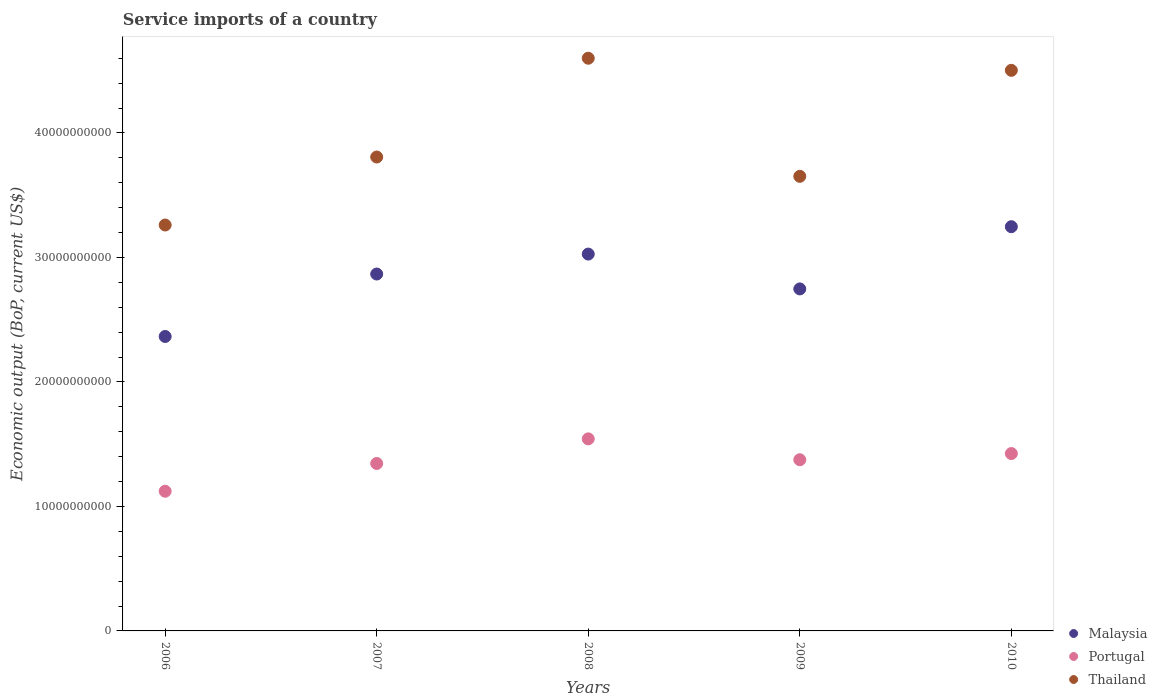How many different coloured dotlines are there?
Make the answer very short. 3. What is the service imports in Portugal in 2009?
Make the answer very short. 1.38e+1. Across all years, what is the maximum service imports in Thailand?
Ensure brevity in your answer.  4.60e+1. Across all years, what is the minimum service imports in Portugal?
Your answer should be very brief. 1.12e+1. What is the total service imports in Portugal in the graph?
Give a very brief answer. 6.81e+1. What is the difference between the service imports in Malaysia in 2008 and that in 2009?
Your answer should be very brief. 2.80e+09. What is the difference between the service imports in Portugal in 2006 and the service imports in Thailand in 2008?
Your response must be concise. -3.48e+1. What is the average service imports in Malaysia per year?
Offer a very short reply. 2.85e+1. In the year 2007, what is the difference between the service imports in Thailand and service imports in Malaysia?
Your response must be concise. 9.40e+09. What is the ratio of the service imports in Thailand in 2006 to that in 2007?
Make the answer very short. 0.86. Is the service imports in Malaysia in 2006 less than that in 2009?
Provide a short and direct response. Yes. What is the difference between the highest and the second highest service imports in Portugal?
Keep it short and to the point. 1.18e+09. What is the difference between the highest and the lowest service imports in Portugal?
Provide a succinct answer. 4.21e+09. Is the sum of the service imports in Thailand in 2007 and 2008 greater than the maximum service imports in Portugal across all years?
Your answer should be compact. Yes. Is it the case that in every year, the sum of the service imports in Portugal and service imports in Thailand  is greater than the service imports in Malaysia?
Offer a terse response. Yes. Does the service imports in Thailand monotonically increase over the years?
Make the answer very short. No. Is the service imports in Malaysia strictly less than the service imports in Thailand over the years?
Make the answer very short. Yes. How many dotlines are there?
Your response must be concise. 3. How many years are there in the graph?
Your answer should be very brief. 5. What is the difference between two consecutive major ticks on the Y-axis?
Give a very brief answer. 1.00e+1. Does the graph contain any zero values?
Keep it short and to the point. No. Does the graph contain grids?
Ensure brevity in your answer.  No. How are the legend labels stacked?
Your answer should be very brief. Vertical. What is the title of the graph?
Give a very brief answer. Service imports of a country. What is the label or title of the X-axis?
Ensure brevity in your answer.  Years. What is the label or title of the Y-axis?
Offer a very short reply. Economic output (BoP, current US$). What is the Economic output (BoP, current US$) in Malaysia in 2006?
Keep it short and to the point. 2.37e+1. What is the Economic output (BoP, current US$) of Portugal in 2006?
Keep it short and to the point. 1.12e+1. What is the Economic output (BoP, current US$) in Thailand in 2006?
Make the answer very short. 3.26e+1. What is the Economic output (BoP, current US$) of Malaysia in 2007?
Ensure brevity in your answer.  2.87e+1. What is the Economic output (BoP, current US$) of Portugal in 2007?
Keep it short and to the point. 1.34e+1. What is the Economic output (BoP, current US$) in Thailand in 2007?
Offer a terse response. 3.81e+1. What is the Economic output (BoP, current US$) in Malaysia in 2008?
Make the answer very short. 3.03e+1. What is the Economic output (BoP, current US$) of Portugal in 2008?
Offer a terse response. 1.54e+1. What is the Economic output (BoP, current US$) in Thailand in 2008?
Provide a succinct answer. 4.60e+1. What is the Economic output (BoP, current US$) of Malaysia in 2009?
Ensure brevity in your answer.  2.75e+1. What is the Economic output (BoP, current US$) of Portugal in 2009?
Provide a succinct answer. 1.38e+1. What is the Economic output (BoP, current US$) in Thailand in 2009?
Ensure brevity in your answer.  3.65e+1. What is the Economic output (BoP, current US$) of Malaysia in 2010?
Your response must be concise. 3.25e+1. What is the Economic output (BoP, current US$) in Portugal in 2010?
Provide a short and direct response. 1.42e+1. What is the Economic output (BoP, current US$) of Thailand in 2010?
Offer a terse response. 4.50e+1. Across all years, what is the maximum Economic output (BoP, current US$) of Malaysia?
Provide a short and direct response. 3.25e+1. Across all years, what is the maximum Economic output (BoP, current US$) of Portugal?
Offer a very short reply. 1.54e+1. Across all years, what is the maximum Economic output (BoP, current US$) in Thailand?
Offer a terse response. 4.60e+1. Across all years, what is the minimum Economic output (BoP, current US$) of Malaysia?
Your answer should be compact. 2.37e+1. Across all years, what is the minimum Economic output (BoP, current US$) in Portugal?
Your response must be concise. 1.12e+1. Across all years, what is the minimum Economic output (BoP, current US$) in Thailand?
Give a very brief answer. 3.26e+1. What is the total Economic output (BoP, current US$) in Malaysia in the graph?
Your response must be concise. 1.43e+11. What is the total Economic output (BoP, current US$) of Portugal in the graph?
Provide a short and direct response. 6.81e+1. What is the total Economic output (BoP, current US$) in Thailand in the graph?
Provide a short and direct response. 1.98e+11. What is the difference between the Economic output (BoP, current US$) of Malaysia in 2006 and that in 2007?
Offer a terse response. -5.02e+09. What is the difference between the Economic output (BoP, current US$) in Portugal in 2006 and that in 2007?
Give a very brief answer. -2.23e+09. What is the difference between the Economic output (BoP, current US$) in Thailand in 2006 and that in 2007?
Offer a very short reply. -5.46e+09. What is the difference between the Economic output (BoP, current US$) of Malaysia in 2006 and that in 2008?
Your response must be concise. -6.62e+09. What is the difference between the Economic output (BoP, current US$) in Portugal in 2006 and that in 2008?
Provide a short and direct response. -4.21e+09. What is the difference between the Economic output (BoP, current US$) of Thailand in 2006 and that in 2008?
Provide a succinct answer. -1.34e+1. What is the difference between the Economic output (BoP, current US$) of Malaysia in 2006 and that in 2009?
Provide a short and direct response. -3.82e+09. What is the difference between the Economic output (BoP, current US$) of Portugal in 2006 and that in 2009?
Your answer should be very brief. -2.53e+09. What is the difference between the Economic output (BoP, current US$) in Thailand in 2006 and that in 2009?
Provide a short and direct response. -3.91e+09. What is the difference between the Economic output (BoP, current US$) in Malaysia in 2006 and that in 2010?
Ensure brevity in your answer.  -8.82e+09. What is the difference between the Economic output (BoP, current US$) of Portugal in 2006 and that in 2010?
Offer a terse response. -3.03e+09. What is the difference between the Economic output (BoP, current US$) in Thailand in 2006 and that in 2010?
Provide a succinct answer. -1.24e+1. What is the difference between the Economic output (BoP, current US$) of Malaysia in 2007 and that in 2008?
Your answer should be very brief. -1.60e+09. What is the difference between the Economic output (BoP, current US$) of Portugal in 2007 and that in 2008?
Offer a very short reply. -1.98e+09. What is the difference between the Economic output (BoP, current US$) of Thailand in 2007 and that in 2008?
Offer a very short reply. -7.94e+09. What is the difference between the Economic output (BoP, current US$) of Malaysia in 2007 and that in 2009?
Offer a very short reply. 1.20e+09. What is the difference between the Economic output (BoP, current US$) of Portugal in 2007 and that in 2009?
Your response must be concise. -3.01e+08. What is the difference between the Economic output (BoP, current US$) in Thailand in 2007 and that in 2009?
Your answer should be compact. 1.55e+09. What is the difference between the Economic output (BoP, current US$) of Malaysia in 2007 and that in 2010?
Ensure brevity in your answer.  -3.80e+09. What is the difference between the Economic output (BoP, current US$) in Portugal in 2007 and that in 2010?
Make the answer very short. -7.98e+08. What is the difference between the Economic output (BoP, current US$) of Thailand in 2007 and that in 2010?
Give a very brief answer. -6.96e+09. What is the difference between the Economic output (BoP, current US$) in Malaysia in 2008 and that in 2009?
Keep it short and to the point. 2.80e+09. What is the difference between the Economic output (BoP, current US$) of Portugal in 2008 and that in 2009?
Your response must be concise. 1.68e+09. What is the difference between the Economic output (BoP, current US$) of Thailand in 2008 and that in 2009?
Ensure brevity in your answer.  9.49e+09. What is the difference between the Economic output (BoP, current US$) in Malaysia in 2008 and that in 2010?
Offer a very short reply. -2.20e+09. What is the difference between the Economic output (BoP, current US$) in Portugal in 2008 and that in 2010?
Your response must be concise. 1.18e+09. What is the difference between the Economic output (BoP, current US$) in Thailand in 2008 and that in 2010?
Give a very brief answer. 9.72e+08. What is the difference between the Economic output (BoP, current US$) in Malaysia in 2009 and that in 2010?
Ensure brevity in your answer.  -5.00e+09. What is the difference between the Economic output (BoP, current US$) of Portugal in 2009 and that in 2010?
Offer a very short reply. -4.96e+08. What is the difference between the Economic output (BoP, current US$) of Thailand in 2009 and that in 2010?
Give a very brief answer. -8.51e+09. What is the difference between the Economic output (BoP, current US$) of Malaysia in 2006 and the Economic output (BoP, current US$) of Portugal in 2007?
Your response must be concise. 1.02e+1. What is the difference between the Economic output (BoP, current US$) in Malaysia in 2006 and the Economic output (BoP, current US$) in Thailand in 2007?
Your response must be concise. -1.44e+1. What is the difference between the Economic output (BoP, current US$) in Portugal in 2006 and the Economic output (BoP, current US$) in Thailand in 2007?
Provide a short and direct response. -2.68e+1. What is the difference between the Economic output (BoP, current US$) in Malaysia in 2006 and the Economic output (BoP, current US$) in Portugal in 2008?
Make the answer very short. 8.22e+09. What is the difference between the Economic output (BoP, current US$) in Malaysia in 2006 and the Economic output (BoP, current US$) in Thailand in 2008?
Give a very brief answer. -2.24e+1. What is the difference between the Economic output (BoP, current US$) in Portugal in 2006 and the Economic output (BoP, current US$) in Thailand in 2008?
Offer a very short reply. -3.48e+1. What is the difference between the Economic output (BoP, current US$) in Malaysia in 2006 and the Economic output (BoP, current US$) in Portugal in 2009?
Your answer should be very brief. 9.90e+09. What is the difference between the Economic output (BoP, current US$) of Malaysia in 2006 and the Economic output (BoP, current US$) of Thailand in 2009?
Offer a very short reply. -1.29e+1. What is the difference between the Economic output (BoP, current US$) of Portugal in 2006 and the Economic output (BoP, current US$) of Thailand in 2009?
Give a very brief answer. -2.53e+1. What is the difference between the Economic output (BoP, current US$) in Malaysia in 2006 and the Economic output (BoP, current US$) in Portugal in 2010?
Provide a short and direct response. 9.40e+09. What is the difference between the Economic output (BoP, current US$) in Malaysia in 2006 and the Economic output (BoP, current US$) in Thailand in 2010?
Ensure brevity in your answer.  -2.14e+1. What is the difference between the Economic output (BoP, current US$) of Portugal in 2006 and the Economic output (BoP, current US$) of Thailand in 2010?
Provide a short and direct response. -3.38e+1. What is the difference between the Economic output (BoP, current US$) of Malaysia in 2007 and the Economic output (BoP, current US$) of Portugal in 2008?
Offer a very short reply. 1.32e+1. What is the difference between the Economic output (BoP, current US$) in Malaysia in 2007 and the Economic output (BoP, current US$) in Thailand in 2008?
Provide a short and direct response. -1.73e+1. What is the difference between the Economic output (BoP, current US$) of Portugal in 2007 and the Economic output (BoP, current US$) of Thailand in 2008?
Provide a short and direct response. -3.26e+1. What is the difference between the Economic output (BoP, current US$) of Malaysia in 2007 and the Economic output (BoP, current US$) of Portugal in 2009?
Keep it short and to the point. 1.49e+1. What is the difference between the Economic output (BoP, current US$) of Malaysia in 2007 and the Economic output (BoP, current US$) of Thailand in 2009?
Offer a very short reply. -7.85e+09. What is the difference between the Economic output (BoP, current US$) of Portugal in 2007 and the Economic output (BoP, current US$) of Thailand in 2009?
Give a very brief answer. -2.31e+1. What is the difference between the Economic output (BoP, current US$) of Malaysia in 2007 and the Economic output (BoP, current US$) of Portugal in 2010?
Your answer should be compact. 1.44e+1. What is the difference between the Economic output (BoP, current US$) of Malaysia in 2007 and the Economic output (BoP, current US$) of Thailand in 2010?
Your answer should be compact. -1.64e+1. What is the difference between the Economic output (BoP, current US$) in Portugal in 2007 and the Economic output (BoP, current US$) in Thailand in 2010?
Provide a short and direct response. -3.16e+1. What is the difference between the Economic output (BoP, current US$) in Malaysia in 2008 and the Economic output (BoP, current US$) in Portugal in 2009?
Give a very brief answer. 1.65e+1. What is the difference between the Economic output (BoP, current US$) of Malaysia in 2008 and the Economic output (BoP, current US$) of Thailand in 2009?
Make the answer very short. -6.24e+09. What is the difference between the Economic output (BoP, current US$) in Portugal in 2008 and the Economic output (BoP, current US$) in Thailand in 2009?
Provide a short and direct response. -2.11e+1. What is the difference between the Economic output (BoP, current US$) in Malaysia in 2008 and the Economic output (BoP, current US$) in Portugal in 2010?
Your response must be concise. 1.60e+1. What is the difference between the Economic output (BoP, current US$) in Malaysia in 2008 and the Economic output (BoP, current US$) in Thailand in 2010?
Provide a short and direct response. -1.48e+1. What is the difference between the Economic output (BoP, current US$) in Portugal in 2008 and the Economic output (BoP, current US$) in Thailand in 2010?
Your answer should be very brief. -2.96e+1. What is the difference between the Economic output (BoP, current US$) of Malaysia in 2009 and the Economic output (BoP, current US$) of Portugal in 2010?
Offer a very short reply. 1.32e+1. What is the difference between the Economic output (BoP, current US$) of Malaysia in 2009 and the Economic output (BoP, current US$) of Thailand in 2010?
Your answer should be compact. -1.76e+1. What is the difference between the Economic output (BoP, current US$) of Portugal in 2009 and the Economic output (BoP, current US$) of Thailand in 2010?
Ensure brevity in your answer.  -3.13e+1. What is the average Economic output (BoP, current US$) of Malaysia per year?
Give a very brief answer. 2.85e+1. What is the average Economic output (BoP, current US$) of Portugal per year?
Offer a very short reply. 1.36e+1. What is the average Economic output (BoP, current US$) in Thailand per year?
Make the answer very short. 3.96e+1. In the year 2006, what is the difference between the Economic output (BoP, current US$) in Malaysia and Economic output (BoP, current US$) in Portugal?
Provide a succinct answer. 1.24e+1. In the year 2006, what is the difference between the Economic output (BoP, current US$) of Malaysia and Economic output (BoP, current US$) of Thailand?
Give a very brief answer. -8.95e+09. In the year 2006, what is the difference between the Economic output (BoP, current US$) of Portugal and Economic output (BoP, current US$) of Thailand?
Offer a terse response. -2.14e+1. In the year 2007, what is the difference between the Economic output (BoP, current US$) in Malaysia and Economic output (BoP, current US$) in Portugal?
Ensure brevity in your answer.  1.52e+1. In the year 2007, what is the difference between the Economic output (BoP, current US$) of Malaysia and Economic output (BoP, current US$) of Thailand?
Make the answer very short. -9.40e+09. In the year 2007, what is the difference between the Economic output (BoP, current US$) in Portugal and Economic output (BoP, current US$) in Thailand?
Ensure brevity in your answer.  -2.46e+1. In the year 2008, what is the difference between the Economic output (BoP, current US$) of Malaysia and Economic output (BoP, current US$) of Portugal?
Offer a very short reply. 1.48e+1. In the year 2008, what is the difference between the Economic output (BoP, current US$) in Malaysia and Economic output (BoP, current US$) in Thailand?
Provide a succinct answer. -1.57e+1. In the year 2008, what is the difference between the Economic output (BoP, current US$) of Portugal and Economic output (BoP, current US$) of Thailand?
Keep it short and to the point. -3.06e+1. In the year 2009, what is the difference between the Economic output (BoP, current US$) in Malaysia and Economic output (BoP, current US$) in Portugal?
Ensure brevity in your answer.  1.37e+1. In the year 2009, what is the difference between the Economic output (BoP, current US$) of Malaysia and Economic output (BoP, current US$) of Thailand?
Offer a very short reply. -9.04e+09. In the year 2009, what is the difference between the Economic output (BoP, current US$) in Portugal and Economic output (BoP, current US$) in Thailand?
Make the answer very short. -2.28e+1. In the year 2010, what is the difference between the Economic output (BoP, current US$) of Malaysia and Economic output (BoP, current US$) of Portugal?
Ensure brevity in your answer.  1.82e+1. In the year 2010, what is the difference between the Economic output (BoP, current US$) of Malaysia and Economic output (BoP, current US$) of Thailand?
Ensure brevity in your answer.  -1.26e+1. In the year 2010, what is the difference between the Economic output (BoP, current US$) in Portugal and Economic output (BoP, current US$) in Thailand?
Your answer should be very brief. -3.08e+1. What is the ratio of the Economic output (BoP, current US$) in Malaysia in 2006 to that in 2007?
Ensure brevity in your answer.  0.82. What is the ratio of the Economic output (BoP, current US$) in Portugal in 2006 to that in 2007?
Give a very brief answer. 0.83. What is the ratio of the Economic output (BoP, current US$) of Thailand in 2006 to that in 2007?
Your answer should be very brief. 0.86. What is the ratio of the Economic output (BoP, current US$) of Malaysia in 2006 to that in 2008?
Ensure brevity in your answer.  0.78. What is the ratio of the Economic output (BoP, current US$) of Portugal in 2006 to that in 2008?
Make the answer very short. 0.73. What is the ratio of the Economic output (BoP, current US$) of Thailand in 2006 to that in 2008?
Provide a succinct answer. 0.71. What is the ratio of the Economic output (BoP, current US$) of Malaysia in 2006 to that in 2009?
Provide a short and direct response. 0.86. What is the ratio of the Economic output (BoP, current US$) of Portugal in 2006 to that in 2009?
Provide a short and direct response. 0.82. What is the ratio of the Economic output (BoP, current US$) in Thailand in 2006 to that in 2009?
Ensure brevity in your answer.  0.89. What is the ratio of the Economic output (BoP, current US$) in Malaysia in 2006 to that in 2010?
Make the answer very short. 0.73. What is the ratio of the Economic output (BoP, current US$) in Portugal in 2006 to that in 2010?
Provide a short and direct response. 0.79. What is the ratio of the Economic output (BoP, current US$) of Thailand in 2006 to that in 2010?
Give a very brief answer. 0.72. What is the ratio of the Economic output (BoP, current US$) of Malaysia in 2007 to that in 2008?
Your answer should be very brief. 0.95. What is the ratio of the Economic output (BoP, current US$) of Portugal in 2007 to that in 2008?
Offer a terse response. 0.87. What is the ratio of the Economic output (BoP, current US$) in Thailand in 2007 to that in 2008?
Your answer should be very brief. 0.83. What is the ratio of the Economic output (BoP, current US$) in Malaysia in 2007 to that in 2009?
Your answer should be compact. 1.04. What is the ratio of the Economic output (BoP, current US$) in Portugal in 2007 to that in 2009?
Provide a short and direct response. 0.98. What is the ratio of the Economic output (BoP, current US$) in Thailand in 2007 to that in 2009?
Give a very brief answer. 1.04. What is the ratio of the Economic output (BoP, current US$) of Malaysia in 2007 to that in 2010?
Offer a terse response. 0.88. What is the ratio of the Economic output (BoP, current US$) in Portugal in 2007 to that in 2010?
Ensure brevity in your answer.  0.94. What is the ratio of the Economic output (BoP, current US$) of Thailand in 2007 to that in 2010?
Provide a short and direct response. 0.85. What is the ratio of the Economic output (BoP, current US$) in Malaysia in 2008 to that in 2009?
Your response must be concise. 1.1. What is the ratio of the Economic output (BoP, current US$) of Portugal in 2008 to that in 2009?
Your response must be concise. 1.12. What is the ratio of the Economic output (BoP, current US$) of Thailand in 2008 to that in 2009?
Ensure brevity in your answer.  1.26. What is the ratio of the Economic output (BoP, current US$) in Malaysia in 2008 to that in 2010?
Your answer should be compact. 0.93. What is the ratio of the Economic output (BoP, current US$) of Portugal in 2008 to that in 2010?
Give a very brief answer. 1.08. What is the ratio of the Economic output (BoP, current US$) of Thailand in 2008 to that in 2010?
Keep it short and to the point. 1.02. What is the ratio of the Economic output (BoP, current US$) of Malaysia in 2009 to that in 2010?
Your answer should be compact. 0.85. What is the ratio of the Economic output (BoP, current US$) of Portugal in 2009 to that in 2010?
Give a very brief answer. 0.97. What is the ratio of the Economic output (BoP, current US$) in Thailand in 2009 to that in 2010?
Offer a terse response. 0.81. What is the difference between the highest and the second highest Economic output (BoP, current US$) of Malaysia?
Give a very brief answer. 2.20e+09. What is the difference between the highest and the second highest Economic output (BoP, current US$) in Portugal?
Make the answer very short. 1.18e+09. What is the difference between the highest and the second highest Economic output (BoP, current US$) of Thailand?
Make the answer very short. 9.72e+08. What is the difference between the highest and the lowest Economic output (BoP, current US$) of Malaysia?
Offer a very short reply. 8.82e+09. What is the difference between the highest and the lowest Economic output (BoP, current US$) of Portugal?
Your response must be concise. 4.21e+09. What is the difference between the highest and the lowest Economic output (BoP, current US$) of Thailand?
Your answer should be very brief. 1.34e+1. 